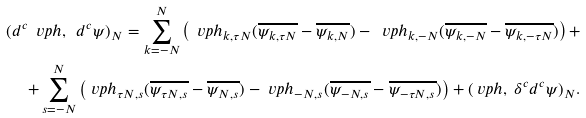<formula> <loc_0><loc_0><loc_500><loc_500>( d ^ { c } \ v p h , \ d ^ { c } \psi ) _ { N } = \sum _ { k = - N } ^ { N } \left ( \ v p h _ { k , \tau N } ( \overline { \psi _ { k , \tau N } } - \overline { \psi _ { k , N } } ) - \ v p h _ { k , - N } ( \overline { \psi _ { k , - N } } - \overline { \psi _ { k , - \tau N } } ) \right ) + \\ + \sum _ { s = - N } ^ { N } \left ( \ v p h _ { \tau N , s } ( \overline { \psi _ { \tau N , s } } - \overline { \psi _ { N , s } } ) - \ v p h _ { - N , s } ( \overline { \psi _ { - N , s } } - \overline { \psi _ { - \tau N , s } } ) \right ) + ( \ v p h , \ \delta ^ { c } d ^ { c } \psi ) _ { N } .</formula> 